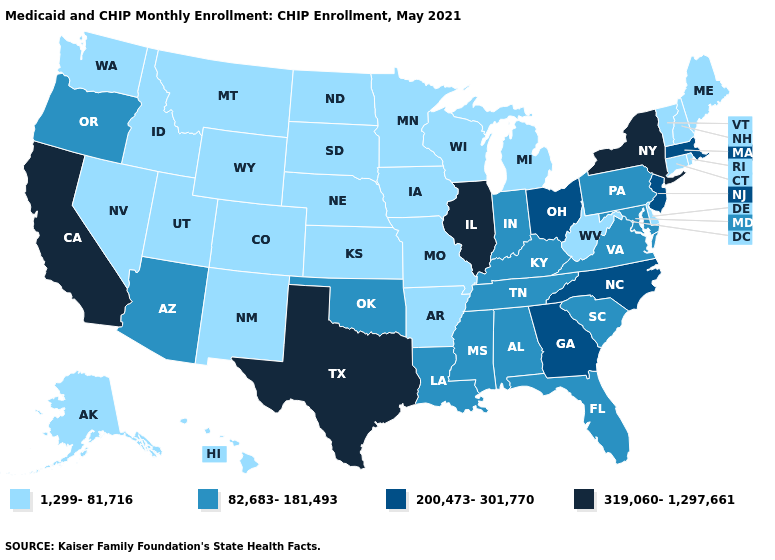Name the states that have a value in the range 82,683-181,493?
Answer briefly. Alabama, Arizona, Florida, Indiana, Kentucky, Louisiana, Maryland, Mississippi, Oklahoma, Oregon, Pennsylvania, South Carolina, Tennessee, Virginia. Name the states that have a value in the range 1,299-81,716?
Concise answer only. Alaska, Arkansas, Colorado, Connecticut, Delaware, Hawaii, Idaho, Iowa, Kansas, Maine, Michigan, Minnesota, Missouri, Montana, Nebraska, Nevada, New Hampshire, New Mexico, North Dakota, Rhode Island, South Dakota, Utah, Vermont, Washington, West Virginia, Wisconsin, Wyoming. What is the value of North Carolina?
Short answer required. 200,473-301,770. Name the states that have a value in the range 1,299-81,716?
Short answer required. Alaska, Arkansas, Colorado, Connecticut, Delaware, Hawaii, Idaho, Iowa, Kansas, Maine, Michigan, Minnesota, Missouri, Montana, Nebraska, Nevada, New Hampshire, New Mexico, North Dakota, Rhode Island, South Dakota, Utah, Vermont, Washington, West Virginia, Wisconsin, Wyoming. What is the value of Maryland?
Answer briefly. 82,683-181,493. Which states have the lowest value in the South?
Write a very short answer. Arkansas, Delaware, West Virginia. Name the states that have a value in the range 82,683-181,493?
Be succinct. Alabama, Arizona, Florida, Indiana, Kentucky, Louisiana, Maryland, Mississippi, Oklahoma, Oregon, Pennsylvania, South Carolina, Tennessee, Virginia. Does Alabama have the highest value in the USA?
Give a very brief answer. No. What is the highest value in the South ?
Quick response, please. 319,060-1,297,661. What is the highest value in the South ?
Answer briefly. 319,060-1,297,661. Name the states that have a value in the range 82,683-181,493?
Concise answer only. Alabama, Arizona, Florida, Indiana, Kentucky, Louisiana, Maryland, Mississippi, Oklahoma, Oregon, Pennsylvania, South Carolina, Tennessee, Virginia. Name the states that have a value in the range 82,683-181,493?
Short answer required. Alabama, Arizona, Florida, Indiana, Kentucky, Louisiana, Maryland, Mississippi, Oklahoma, Oregon, Pennsylvania, South Carolina, Tennessee, Virginia. What is the lowest value in the USA?
Be succinct. 1,299-81,716. What is the value of Delaware?
Write a very short answer. 1,299-81,716. 